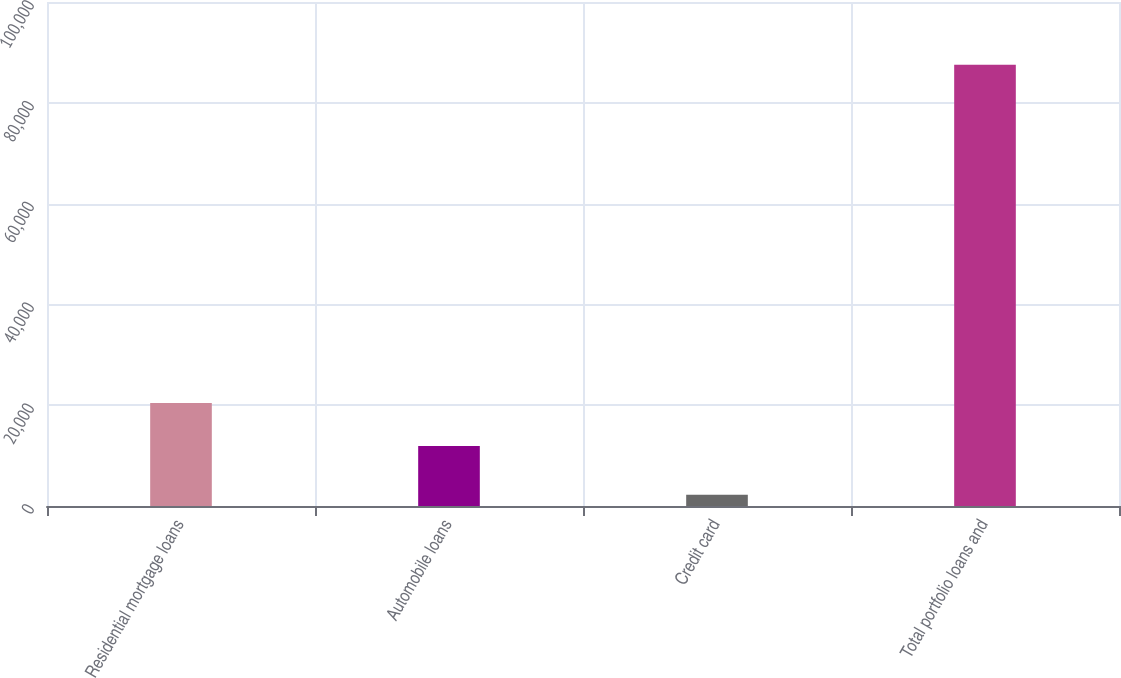Convert chart. <chart><loc_0><loc_0><loc_500><loc_500><bar_chart><fcel>Residential mortgage loans<fcel>Automobile loans<fcel>Credit card<fcel>Total portfolio loans and<nl><fcel>20449.9<fcel>11919<fcel>2225<fcel>87534<nl></chart> 